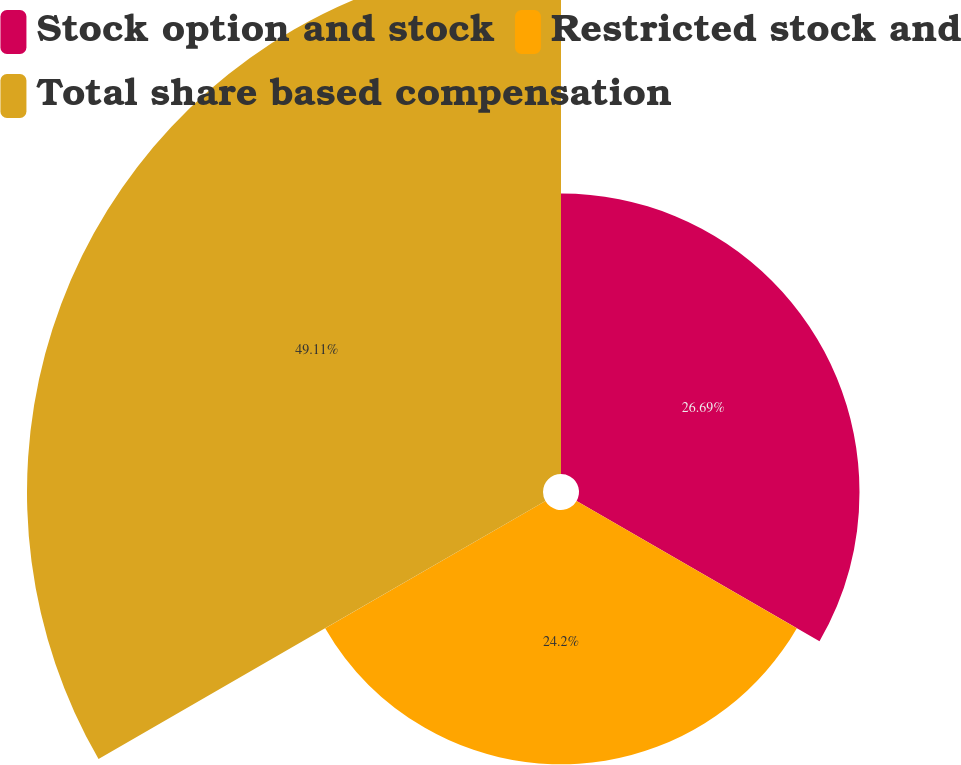Convert chart. <chart><loc_0><loc_0><loc_500><loc_500><pie_chart><fcel>Stock option and stock<fcel>Restricted stock and<fcel>Total share based compensation<nl><fcel>26.69%<fcel>24.2%<fcel>49.1%<nl></chart> 